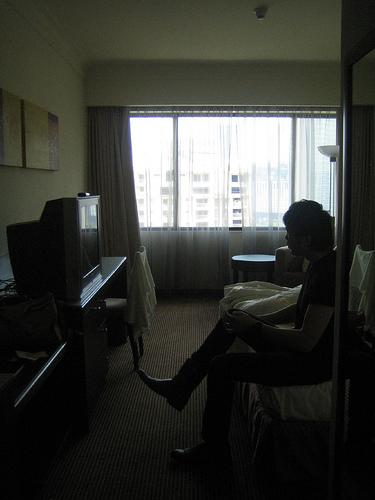Where is the woman sitting in? Please explain your reasoning. hotel room. The woman is in a room that has a mirror and tv, which indicates she's in a hotel. 